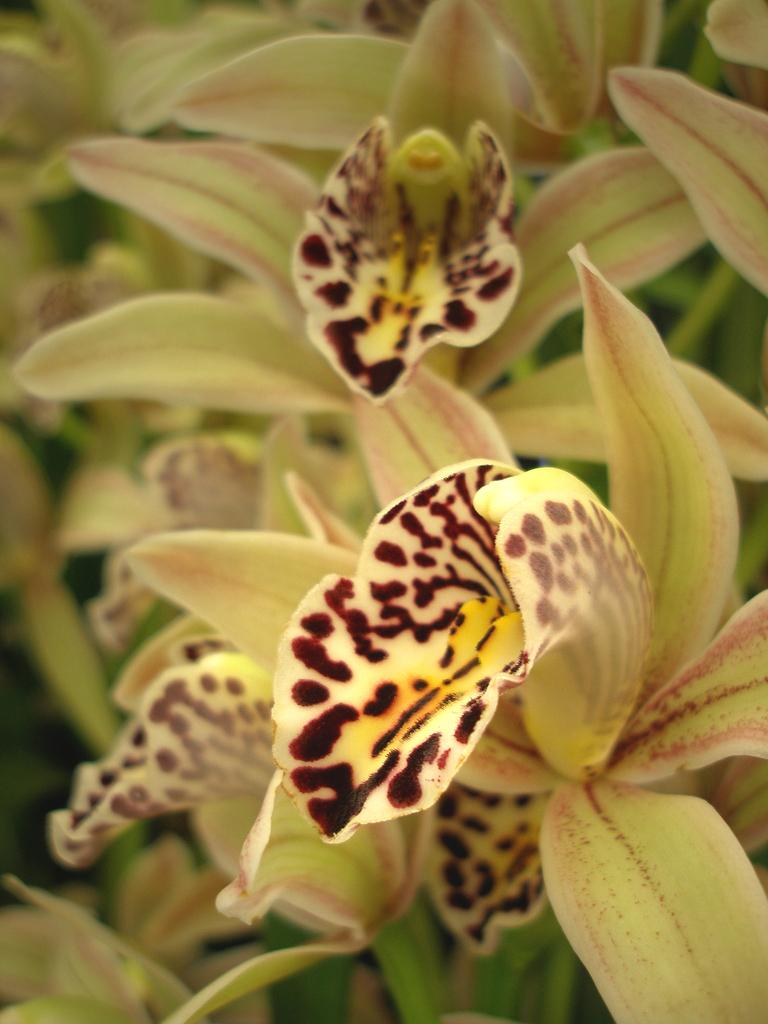What type of living organisms can be seen in the image? Flowers can be seen in the image. Can you describe the flowers in the image? Unfortunately, the facts provided do not give any details about the flowers' appearance or characteristics. What might be the purpose of the flowers in the image? The purpose of the flowers in the image cannot be determined without additional context or information. How many stamps are required to expand the flowers in the image? There are no stamps present in the image, and flowers do not require stamps for expansion. 